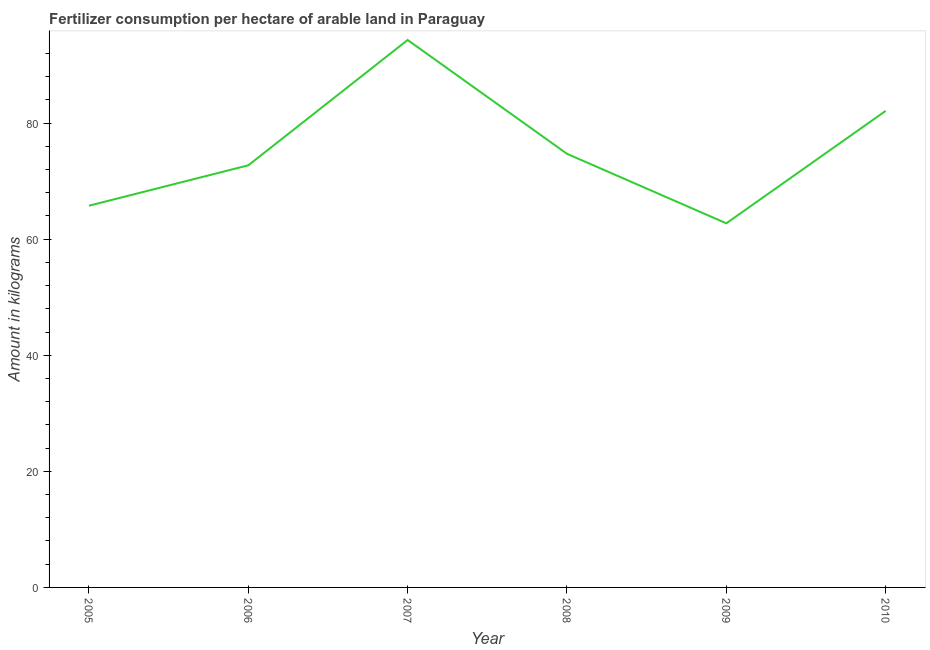What is the amount of fertilizer consumption in 2006?
Offer a very short reply. 72.72. Across all years, what is the maximum amount of fertilizer consumption?
Ensure brevity in your answer.  94.31. Across all years, what is the minimum amount of fertilizer consumption?
Offer a terse response. 62.73. In which year was the amount of fertilizer consumption minimum?
Your answer should be compact. 2009. What is the sum of the amount of fertilizer consumption?
Your answer should be compact. 452.32. What is the difference between the amount of fertilizer consumption in 2007 and 2010?
Offer a very short reply. 12.22. What is the average amount of fertilizer consumption per year?
Your answer should be very brief. 75.39. What is the median amount of fertilizer consumption?
Offer a terse response. 73.71. In how many years, is the amount of fertilizer consumption greater than 84 kg?
Provide a succinct answer. 1. What is the ratio of the amount of fertilizer consumption in 2007 to that in 2008?
Give a very brief answer. 1.26. What is the difference between the highest and the second highest amount of fertilizer consumption?
Your answer should be very brief. 12.22. What is the difference between the highest and the lowest amount of fertilizer consumption?
Offer a terse response. 31.58. Does the amount of fertilizer consumption monotonically increase over the years?
Offer a terse response. No. What is the difference between two consecutive major ticks on the Y-axis?
Provide a succinct answer. 20. Does the graph contain any zero values?
Offer a terse response. No. Does the graph contain grids?
Offer a very short reply. No. What is the title of the graph?
Offer a very short reply. Fertilizer consumption per hectare of arable land in Paraguay . What is the label or title of the Y-axis?
Your answer should be compact. Amount in kilograms. What is the Amount in kilograms of 2005?
Offer a terse response. 65.76. What is the Amount in kilograms of 2006?
Your answer should be very brief. 72.72. What is the Amount in kilograms in 2007?
Offer a very short reply. 94.31. What is the Amount in kilograms in 2008?
Provide a short and direct response. 74.7. What is the Amount in kilograms of 2009?
Your answer should be compact. 62.73. What is the Amount in kilograms in 2010?
Make the answer very short. 82.1. What is the difference between the Amount in kilograms in 2005 and 2006?
Make the answer very short. -6.96. What is the difference between the Amount in kilograms in 2005 and 2007?
Give a very brief answer. -28.55. What is the difference between the Amount in kilograms in 2005 and 2008?
Provide a short and direct response. -8.94. What is the difference between the Amount in kilograms in 2005 and 2009?
Your answer should be very brief. 3.03. What is the difference between the Amount in kilograms in 2005 and 2010?
Your response must be concise. -16.33. What is the difference between the Amount in kilograms in 2006 and 2007?
Provide a succinct answer. -21.59. What is the difference between the Amount in kilograms in 2006 and 2008?
Keep it short and to the point. -1.98. What is the difference between the Amount in kilograms in 2006 and 2009?
Your answer should be compact. 9.99. What is the difference between the Amount in kilograms in 2006 and 2010?
Your answer should be very brief. -9.37. What is the difference between the Amount in kilograms in 2007 and 2008?
Ensure brevity in your answer.  19.61. What is the difference between the Amount in kilograms in 2007 and 2009?
Offer a very short reply. 31.58. What is the difference between the Amount in kilograms in 2007 and 2010?
Provide a succinct answer. 12.22. What is the difference between the Amount in kilograms in 2008 and 2009?
Provide a succinct answer. 11.98. What is the difference between the Amount in kilograms in 2008 and 2010?
Offer a very short reply. -7.39. What is the difference between the Amount in kilograms in 2009 and 2010?
Offer a terse response. -19.37. What is the ratio of the Amount in kilograms in 2005 to that in 2006?
Keep it short and to the point. 0.9. What is the ratio of the Amount in kilograms in 2005 to that in 2007?
Your answer should be very brief. 0.7. What is the ratio of the Amount in kilograms in 2005 to that in 2008?
Your answer should be compact. 0.88. What is the ratio of the Amount in kilograms in 2005 to that in 2009?
Keep it short and to the point. 1.05. What is the ratio of the Amount in kilograms in 2005 to that in 2010?
Your response must be concise. 0.8. What is the ratio of the Amount in kilograms in 2006 to that in 2007?
Offer a terse response. 0.77. What is the ratio of the Amount in kilograms in 2006 to that in 2009?
Make the answer very short. 1.16. What is the ratio of the Amount in kilograms in 2006 to that in 2010?
Your response must be concise. 0.89. What is the ratio of the Amount in kilograms in 2007 to that in 2008?
Keep it short and to the point. 1.26. What is the ratio of the Amount in kilograms in 2007 to that in 2009?
Your response must be concise. 1.5. What is the ratio of the Amount in kilograms in 2007 to that in 2010?
Your answer should be compact. 1.15. What is the ratio of the Amount in kilograms in 2008 to that in 2009?
Make the answer very short. 1.19. What is the ratio of the Amount in kilograms in 2008 to that in 2010?
Provide a succinct answer. 0.91. What is the ratio of the Amount in kilograms in 2009 to that in 2010?
Offer a very short reply. 0.76. 